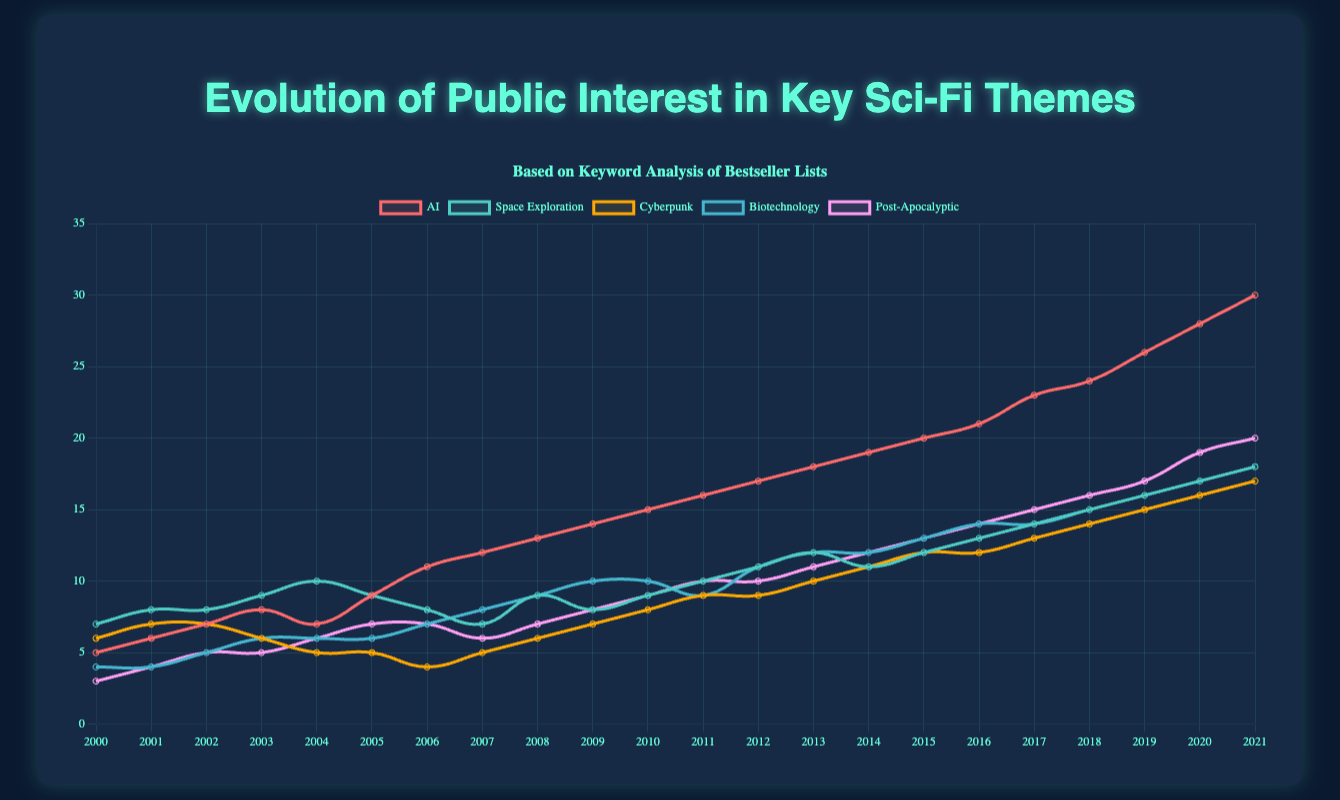Which sci-fi theme had the highest public interest in 2021? The AI theme reached an interest score of 30 in 2021, which is higher than any other theme's score in the same year.
Answer: AI Which year did the Cyberpunk theme see its lowest public interest? The Cyberpunk theme had the lowest public interest, a score of 4, in 2006.
Answer: 2006 Which two themes had equal public interest in 2004? In 2004, both the Biotechnology and Cyberpunk themes had an interest score of 6.
Answer: Biotechnology, Cyberpunk What was the average public interest in Space Exploration from 2000 to 2021? The sum of the interest scores for Space Exploration from 2000 to 2021 is 217. Dividing this sum by the number of years (22) gives an average score of approximately 9.86.
Answer: 9.86 Which theme had the greatest increase in public interest between 2000 and 2021? The AI theme increased by 25 points from 5 in 2000 to 30 in 2021, the most significant increase among all themes.
Answer: AI In what year did the Post-Apocalyptic theme surpass a public interest score of 15? The Post-Apocalyptic theme surpassed a public interest score of 15 in 2018 with a score of 16.
Answer: 2018 How many themes had a higher public interest than Space Exploration in 2009? In 2009, AI (14) and Cyberpunk (7) had higher public interest scores than Space Exploration (8). That makes two themes.
Answer: Two What is the median public interest score for Biotechnology over the entire period? The Biotechnology interest scores are: [4, 4, 5, 6, 6, 6, 7, 8, 9, 10, 10, 9, 11, 12, 12, 13, 14, 14, 15, 16, 17, 18]. The median is the middle value, so for 22 values, it's the average of the 11th and 12th values: (10 + 9) / 2 = 9.5.
Answer: 9.5 Between 2005 and 2010, which theme had the most consistent public interest score without significant drops or surges? The Space Exploration theme had relatively stable interest scores between 7 and 9 from 2005 to 2010.
Answer: Space Exploration In which year do all five themes show an increase in public interest compared to the previous year? In 2001, all five themes (AI, Space Exploration, Cyberpunk, Biotechnology, and Post-Apocalyptic) show an increase in public interest compared to 2000.
Answer: 2001 Keep the number of questions between 5-10 and make sure they are diverse (compositional, comparison, and visual). The answers and explanations must be very detailed, providing step-by-step reasoning 